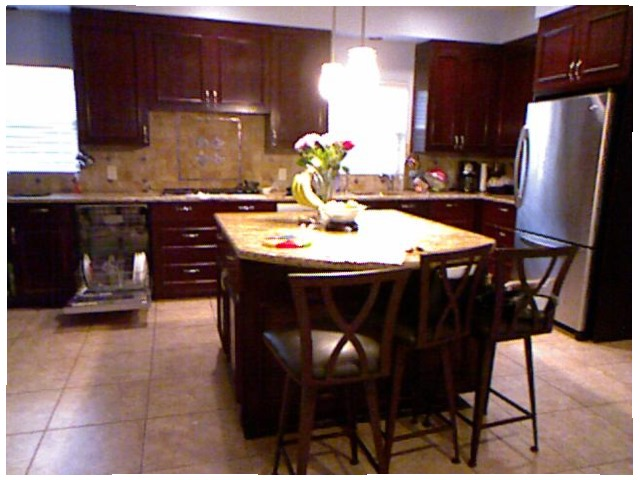<image>
Can you confirm if the table is in front of the chair? Yes. The table is positioned in front of the chair, appearing closer to the camera viewpoint. Where is the table in relation to the chair? Is it behind the chair? Yes. From this viewpoint, the table is positioned behind the chair, with the chair partially or fully occluding the table. 